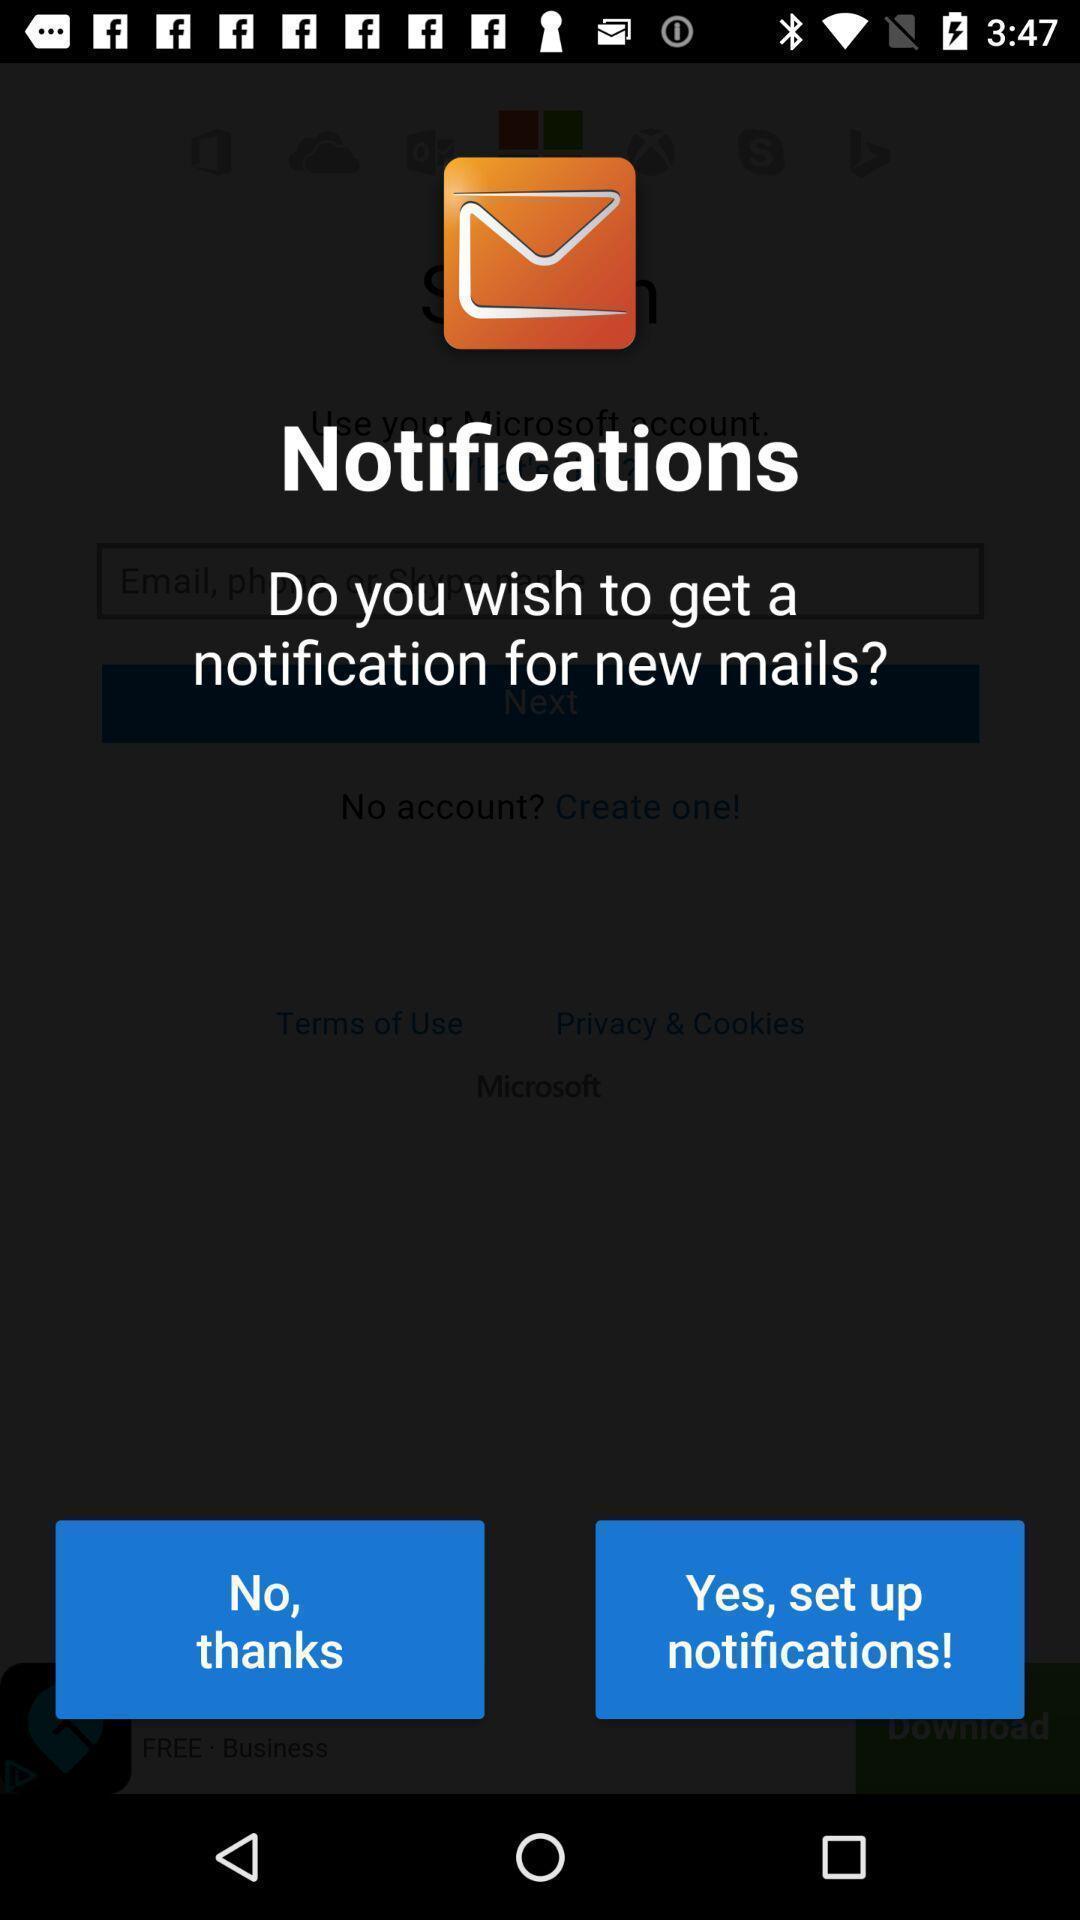Give me a narrative description of this picture. Pop up displaying to set up notifications. 